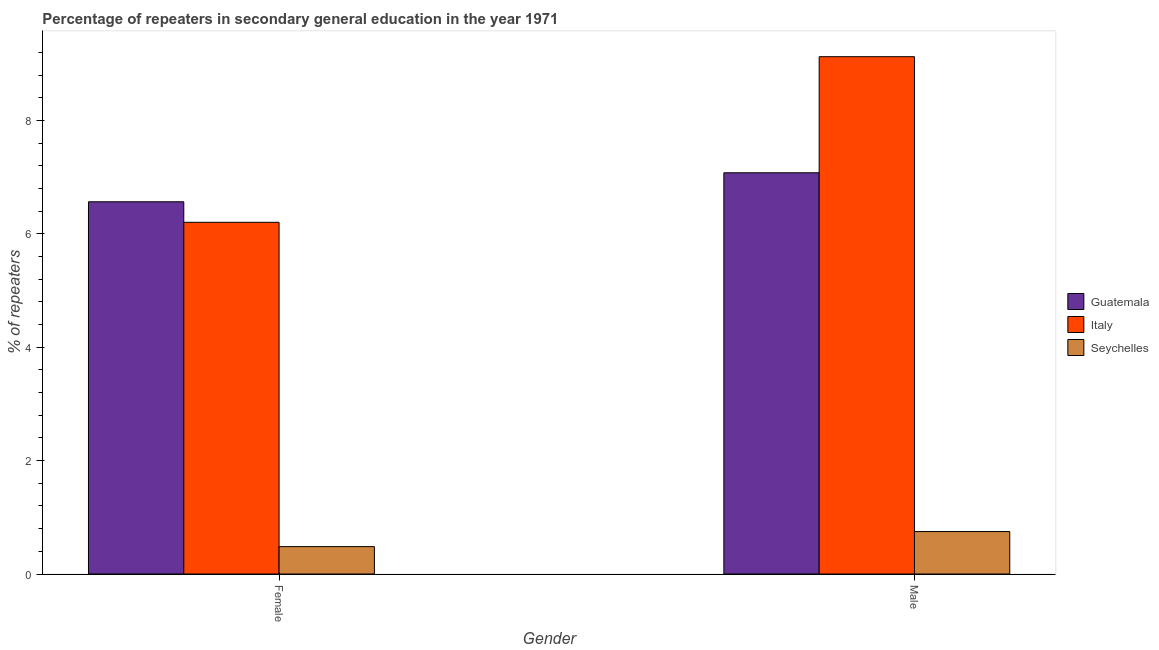Are the number of bars per tick equal to the number of legend labels?
Keep it short and to the point. Yes. Are the number of bars on each tick of the X-axis equal?
Provide a short and direct response. Yes. How many bars are there on the 1st tick from the left?
Offer a very short reply. 3. What is the label of the 2nd group of bars from the left?
Your answer should be very brief. Male. What is the percentage of male repeaters in Seychelles?
Offer a very short reply. 0.75. Across all countries, what is the maximum percentage of female repeaters?
Ensure brevity in your answer.  6.57. Across all countries, what is the minimum percentage of female repeaters?
Your response must be concise. 0.48. In which country was the percentage of male repeaters minimum?
Your response must be concise. Seychelles. What is the total percentage of male repeaters in the graph?
Offer a terse response. 16.96. What is the difference between the percentage of male repeaters in Seychelles and that in Guatemala?
Keep it short and to the point. -6.33. What is the difference between the percentage of male repeaters in Italy and the percentage of female repeaters in Guatemala?
Your answer should be very brief. 2.56. What is the average percentage of female repeaters per country?
Offer a very short reply. 4.42. What is the difference between the percentage of female repeaters and percentage of male repeaters in Guatemala?
Ensure brevity in your answer.  -0.51. In how many countries, is the percentage of female repeaters greater than 2.4 %?
Offer a very short reply. 2. What is the ratio of the percentage of male repeaters in Seychelles to that in Guatemala?
Keep it short and to the point. 0.11. In how many countries, is the percentage of female repeaters greater than the average percentage of female repeaters taken over all countries?
Your answer should be compact. 2. What does the 3rd bar from the right in Male represents?
Make the answer very short. Guatemala. How many bars are there?
Offer a very short reply. 6. Are all the bars in the graph horizontal?
Your response must be concise. No. What is the difference between two consecutive major ticks on the Y-axis?
Provide a succinct answer. 2. Are the values on the major ticks of Y-axis written in scientific E-notation?
Provide a short and direct response. No. Does the graph contain any zero values?
Make the answer very short. No. Where does the legend appear in the graph?
Your answer should be very brief. Center right. How many legend labels are there?
Offer a very short reply. 3. What is the title of the graph?
Provide a short and direct response. Percentage of repeaters in secondary general education in the year 1971. What is the label or title of the X-axis?
Ensure brevity in your answer.  Gender. What is the label or title of the Y-axis?
Ensure brevity in your answer.  % of repeaters. What is the % of repeaters of Guatemala in Female?
Offer a very short reply. 6.57. What is the % of repeaters of Italy in Female?
Make the answer very short. 6.21. What is the % of repeaters of Seychelles in Female?
Your answer should be very brief. 0.48. What is the % of repeaters of Guatemala in Male?
Your response must be concise. 7.08. What is the % of repeaters of Italy in Male?
Provide a succinct answer. 9.13. What is the % of repeaters of Seychelles in Male?
Your response must be concise. 0.75. Across all Gender, what is the maximum % of repeaters of Guatemala?
Give a very brief answer. 7.08. Across all Gender, what is the maximum % of repeaters of Italy?
Offer a terse response. 9.13. Across all Gender, what is the maximum % of repeaters of Seychelles?
Your answer should be very brief. 0.75. Across all Gender, what is the minimum % of repeaters of Guatemala?
Provide a succinct answer. 6.57. Across all Gender, what is the minimum % of repeaters in Italy?
Provide a succinct answer. 6.21. Across all Gender, what is the minimum % of repeaters in Seychelles?
Provide a short and direct response. 0.48. What is the total % of repeaters of Guatemala in the graph?
Make the answer very short. 13.65. What is the total % of repeaters in Italy in the graph?
Provide a short and direct response. 15.33. What is the total % of repeaters in Seychelles in the graph?
Offer a terse response. 1.23. What is the difference between the % of repeaters of Guatemala in Female and that in Male?
Your answer should be very brief. -0.51. What is the difference between the % of repeaters in Italy in Female and that in Male?
Ensure brevity in your answer.  -2.92. What is the difference between the % of repeaters of Seychelles in Female and that in Male?
Ensure brevity in your answer.  -0.27. What is the difference between the % of repeaters in Guatemala in Female and the % of repeaters in Italy in Male?
Offer a terse response. -2.56. What is the difference between the % of repeaters in Guatemala in Female and the % of repeaters in Seychelles in Male?
Offer a terse response. 5.82. What is the difference between the % of repeaters of Italy in Female and the % of repeaters of Seychelles in Male?
Offer a very short reply. 5.46. What is the average % of repeaters in Guatemala per Gender?
Keep it short and to the point. 6.82. What is the average % of repeaters in Italy per Gender?
Ensure brevity in your answer.  7.67. What is the average % of repeaters in Seychelles per Gender?
Keep it short and to the point. 0.62. What is the difference between the % of repeaters in Guatemala and % of repeaters in Italy in Female?
Keep it short and to the point. 0.36. What is the difference between the % of repeaters in Guatemala and % of repeaters in Seychelles in Female?
Your answer should be compact. 6.08. What is the difference between the % of repeaters of Italy and % of repeaters of Seychelles in Female?
Give a very brief answer. 5.72. What is the difference between the % of repeaters in Guatemala and % of repeaters in Italy in Male?
Provide a succinct answer. -2.05. What is the difference between the % of repeaters in Guatemala and % of repeaters in Seychelles in Male?
Your answer should be compact. 6.33. What is the difference between the % of repeaters in Italy and % of repeaters in Seychelles in Male?
Make the answer very short. 8.38. What is the ratio of the % of repeaters of Guatemala in Female to that in Male?
Provide a succinct answer. 0.93. What is the ratio of the % of repeaters in Italy in Female to that in Male?
Make the answer very short. 0.68. What is the ratio of the % of repeaters in Seychelles in Female to that in Male?
Keep it short and to the point. 0.64. What is the difference between the highest and the second highest % of repeaters in Guatemala?
Offer a terse response. 0.51. What is the difference between the highest and the second highest % of repeaters of Italy?
Offer a very short reply. 2.92. What is the difference between the highest and the second highest % of repeaters of Seychelles?
Your answer should be compact. 0.27. What is the difference between the highest and the lowest % of repeaters in Guatemala?
Ensure brevity in your answer.  0.51. What is the difference between the highest and the lowest % of repeaters in Italy?
Your response must be concise. 2.92. What is the difference between the highest and the lowest % of repeaters in Seychelles?
Make the answer very short. 0.27. 